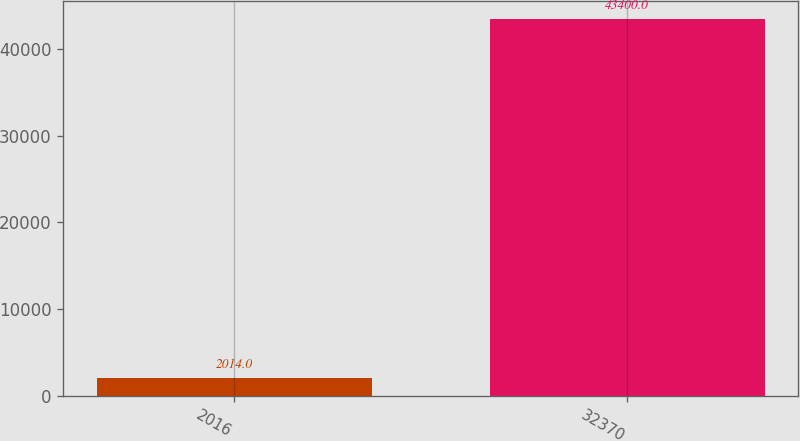<chart> <loc_0><loc_0><loc_500><loc_500><bar_chart><fcel>2016<fcel>32370<nl><fcel>2014<fcel>43400<nl></chart> 